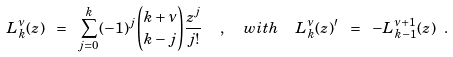<formula> <loc_0><loc_0><loc_500><loc_500>L _ { k } ^ { \nu } ( z ) \ = \ \sum _ { j = 0 } ^ { k } ( - 1 ) ^ { j } \binom { k + \nu } { k - j } \frac { z ^ { j } } { j ! } \ \ , \ \ w i t h \ \ L _ { k } ^ { \nu } ( z ) ^ { \prime } \ = \ - L _ { k - 1 } ^ { \nu + 1 } ( z ) \ .</formula> 